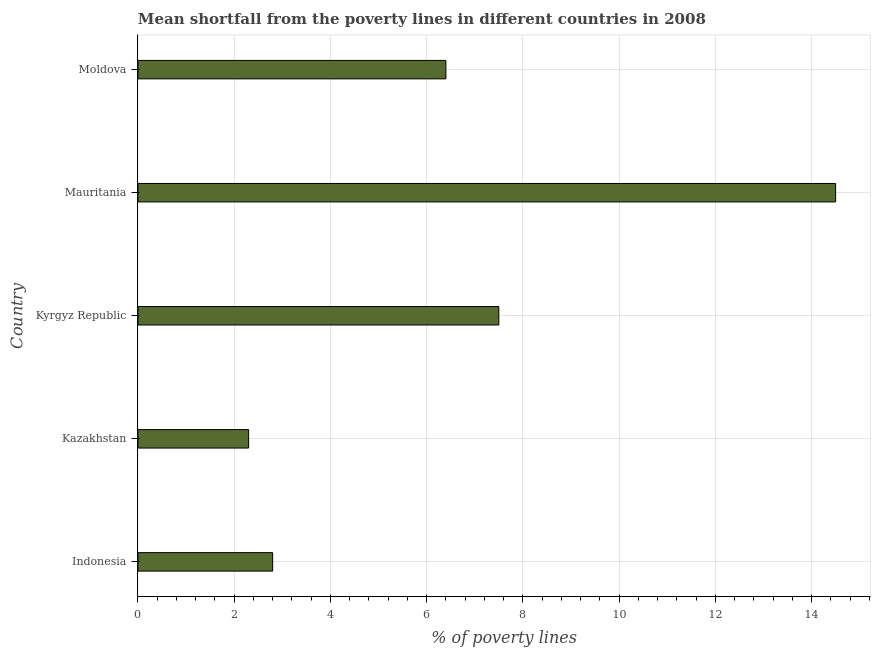What is the title of the graph?
Your answer should be very brief. Mean shortfall from the poverty lines in different countries in 2008. What is the label or title of the X-axis?
Give a very brief answer. % of poverty lines. What is the label or title of the Y-axis?
Give a very brief answer. Country. Across all countries, what is the minimum poverty gap at national poverty lines?
Make the answer very short. 2.3. In which country was the poverty gap at national poverty lines maximum?
Keep it short and to the point. Mauritania. In which country was the poverty gap at national poverty lines minimum?
Ensure brevity in your answer.  Kazakhstan. What is the sum of the poverty gap at national poverty lines?
Ensure brevity in your answer.  33.5. What is the average poverty gap at national poverty lines per country?
Provide a succinct answer. 6.7. What is the median poverty gap at national poverty lines?
Offer a very short reply. 6.4. What is the ratio of the poverty gap at national poverty lines in Kyrgyz Republic to that in Moldova?
Offer a very short reply. 1.17. Is the poverty gap at national poverty lines in Kazakhstan less than that in Kyrgyz Republic?
Offer a terse response. Yes. Is the difference between the poverty gap at national poverty lines in Kazakhstan and Moldova greater than the difference between any two countries?
Your answer should be compact. No. What is the difference between the highest and the second highest poverty gap at national poverty lines?
Your answer should be compact. 7. Is the sum of the poverty gap at national poverty lines in Kyrgyz Republic and Moldova greater than the maximum poverty gap at national poverty lines across all countries?
Offer a very short reply. No. How many countries are there in the graph?
Ensure brevity in your answer.  5. What is the difference between two consecutive major ticks on the X-axis?
Offer a very short reply. 2. What is the % of poverty lines in Mauritania?
Provide a succinct answer. 14.5. What is the difference between the % of poverty lines in Kyrgyz Republic and Mauritania?
Your answer should be very brief. -7. What is the difference between the % of poverty lines in Mauritania and Moldova?
Ensure brevity in your answer.  8.1. What is the ratio of the % of poverty lines in Indonesia to that in Kazakhstan?
Ensure brevity in your answer.  1.22. What is the ratio of the % of poverty lines in Indonesia to that in Kyrgyz Republic?
Make the answer very short. 0.37. What is the ratio of the % of poverty lines in Indonesia to that in Mauritania?
Provide a succinct answer. 0.19. What is the ratio of the % of poverty lines in Indonesia to that in Moldova?
Provide a short and direct response. 0.44. What is the ratio of the % of poverty lines in Kazakhstan to that in Kyrgyz Republic?
Keep it short and to the point. 0.31. What is the ratio of the % of poverty lines in Kazakhstan to that in Mauritania?
Your answer should be compact. 0.16. What is the ratio of the % of poverty lines in Kazakhstan to that in Moldova?
Offer a very short reply. 0.36. What is the ratio of the % of poverty lines in Kyrgyz Republic to that in Mauritania?
Your answer should be very brief. 0.52. What is the ratio of the % of poverty lines in Kyrgyz Republic to that in Moldova?
Your response must be concise. 1.17. What is the ratio of the % of poverty lines in Mauritania to that in Moldova?
Your answer should be compact. 2.27. 